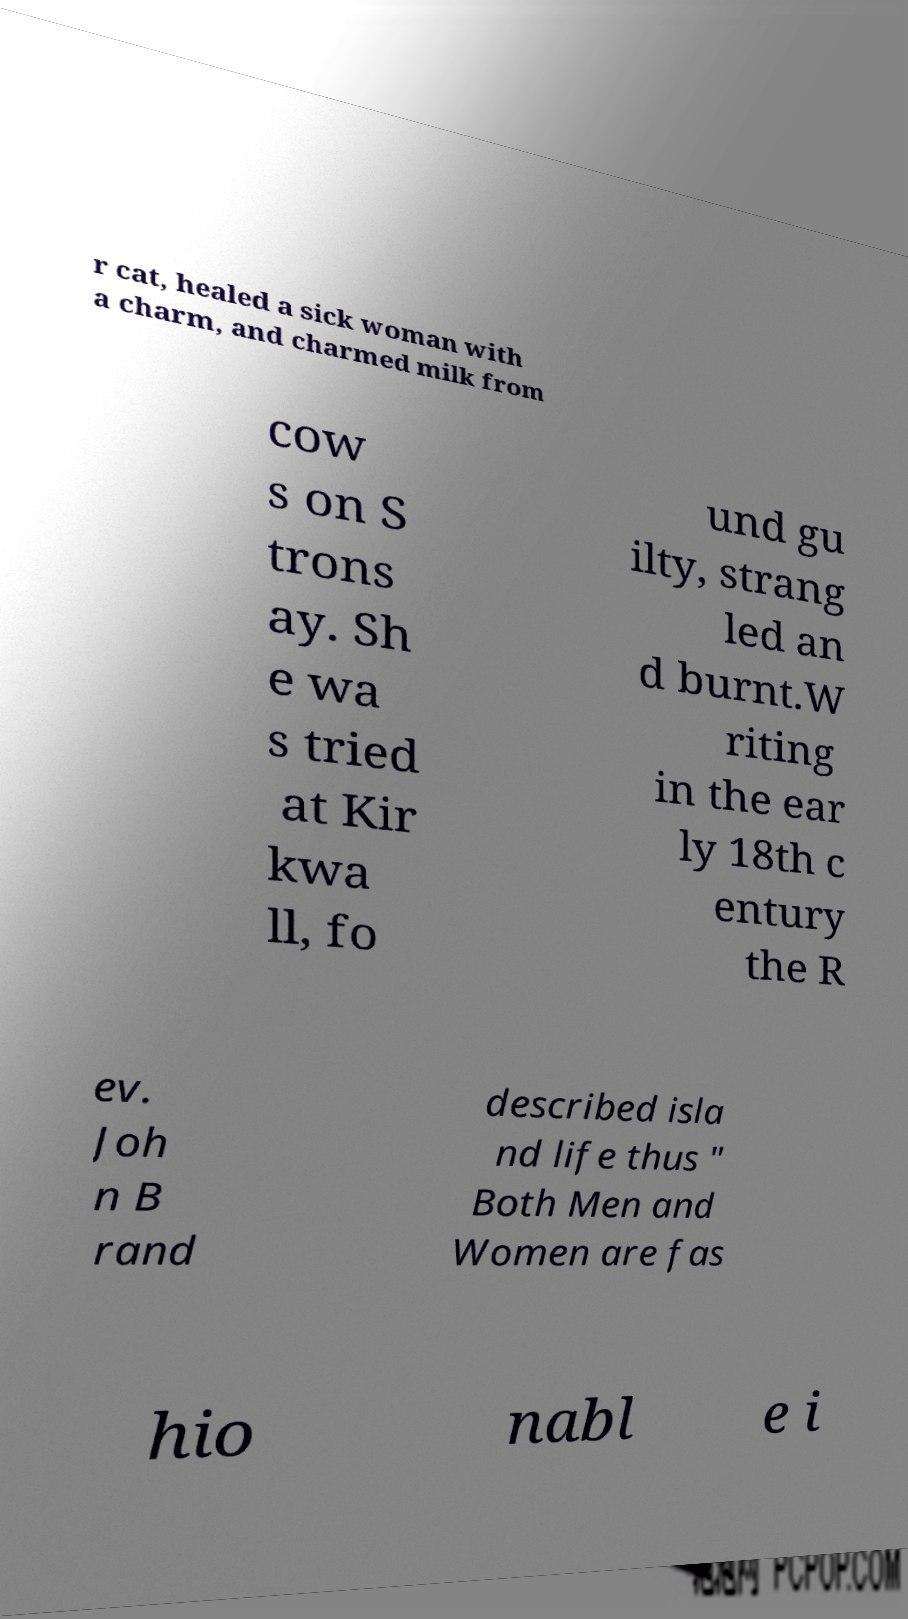Can you accurately transcribe the text from the provided image for me? r cat, healed a sick woman with a charm, and charmed milk from cow s on S trons ay. Sh e wa s tried at Kir kwa ll, fo und gu ilty, strang led an d burnt.W riting in the ear ly 18th c entury the R ev. Joh n B rand described isla nd life thus " Both Men and Women are fas hio nabl e i 